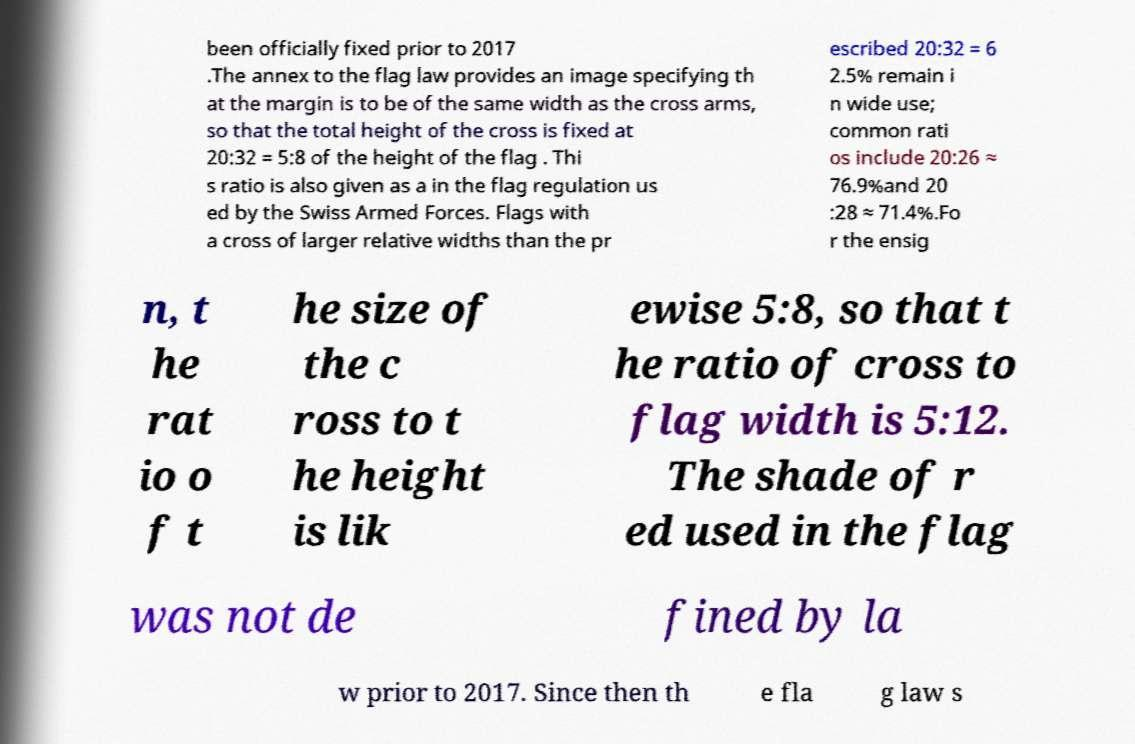I need the written content from this picture converted into text. Can you do that? been officially fixed prior to 2017 .The annex to the flag law provides an image specifying th at the margin is to be of the same width as the cross arms, so that the total height of the cross is fixed at 20:32 = 5:8 of the height of the flag . Thi s ratio is also given as a in the flag regulation us ed by the Swiss Armed Forces. Flags with a cross of larger relative widths than the pr escribed 20:32 = 6 2.5% remain i n wide use; common rati os include 20:26 ≈ 76.9%and 20 :28 ≈ 71.4%.Fo r the ensig n, t he rat io o f t he size of the c ross to t he height is lik ewise 5:8, so that t he ratio of cross to flag width is 5:12. The shade of r ed used in the flag was not de fined by la w prior to 2017. Since then th e fla g law s 